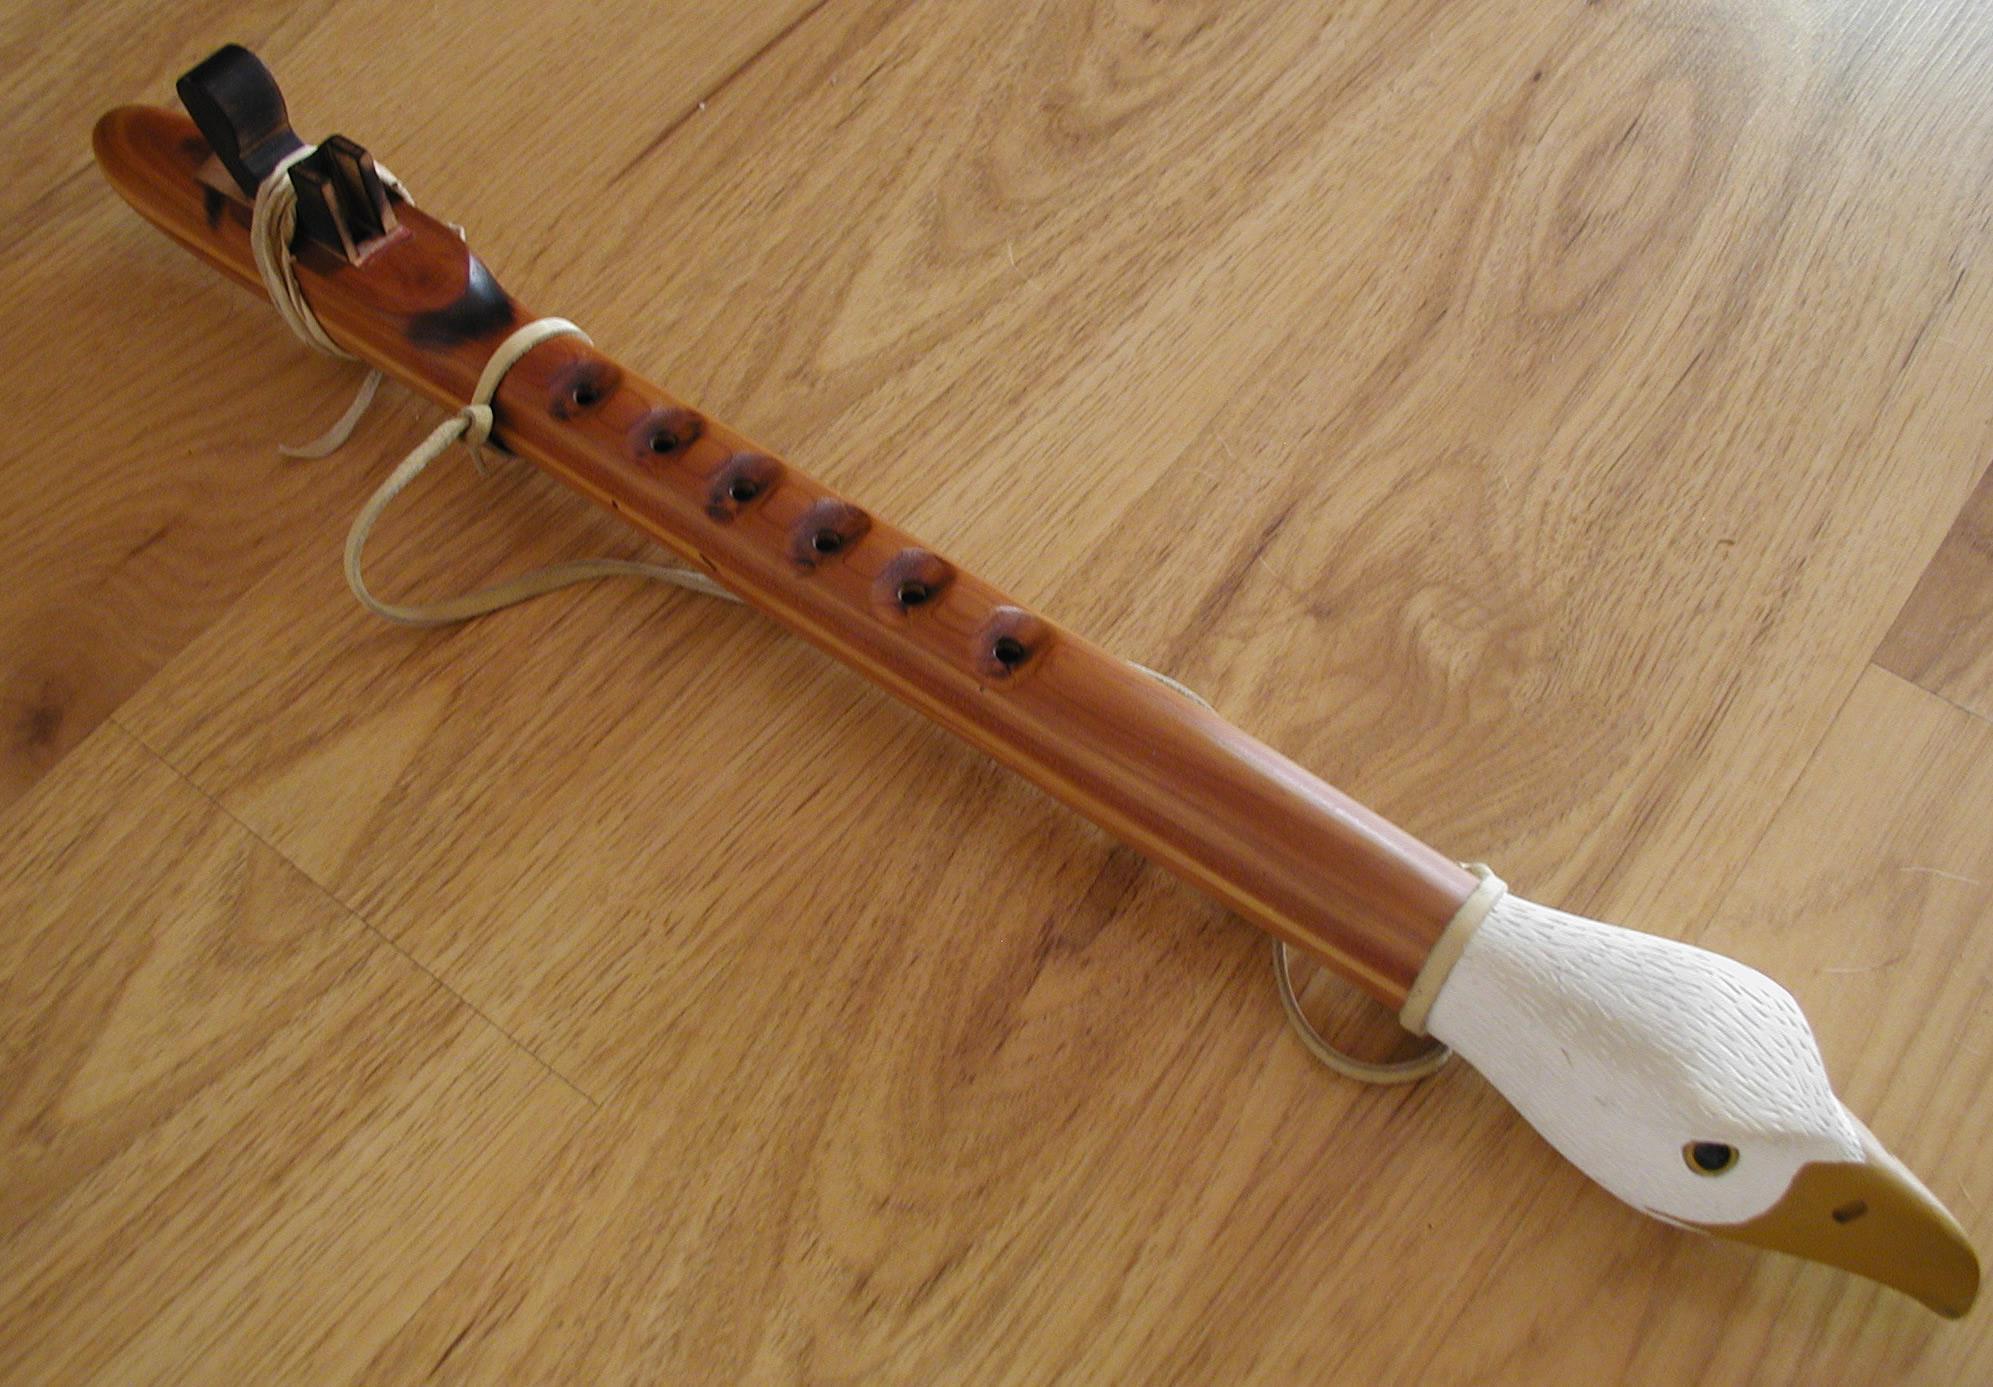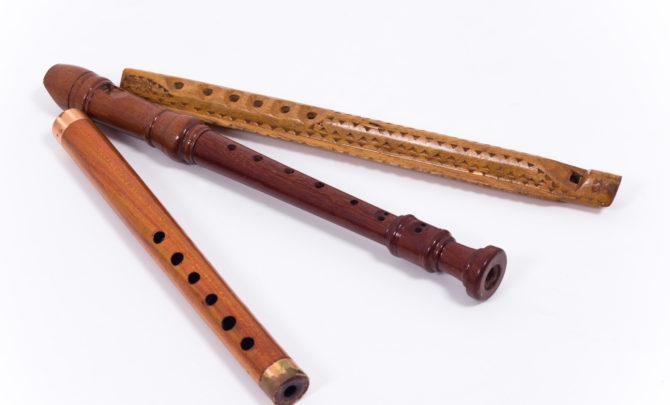The first image is the image on the left, the second image is the image on the right. Evaluate the accuracy of this statement regarding the images: "One image shows at least three flute items fanned out, with ends together at one end.". Is it true? Answer yes or no. Yes. The first image is the image on the left, the second image is the image on the right. Examine the images to the left and right. Is the description "There are at least four recorders." accurate? Answer yes or no. Yes. 